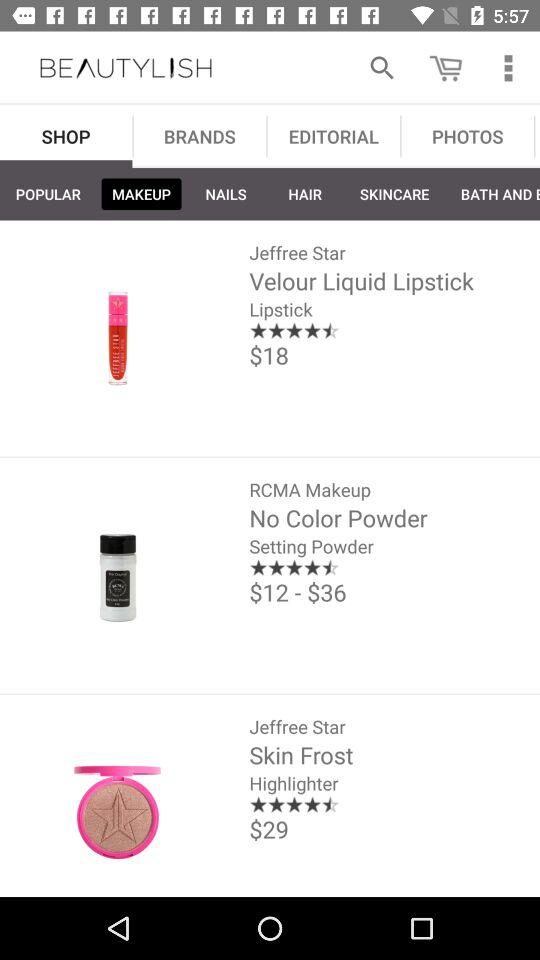What is the price of "Liquid Lipstick"? The price is $18. 